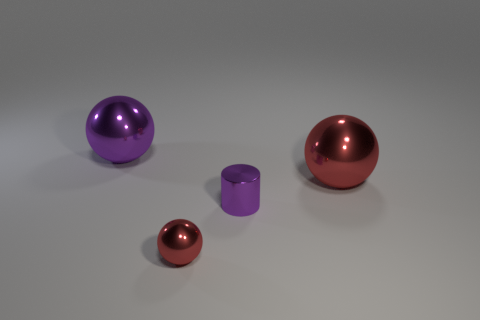How many other small objects are the same shape as the tiny purple object? 0 